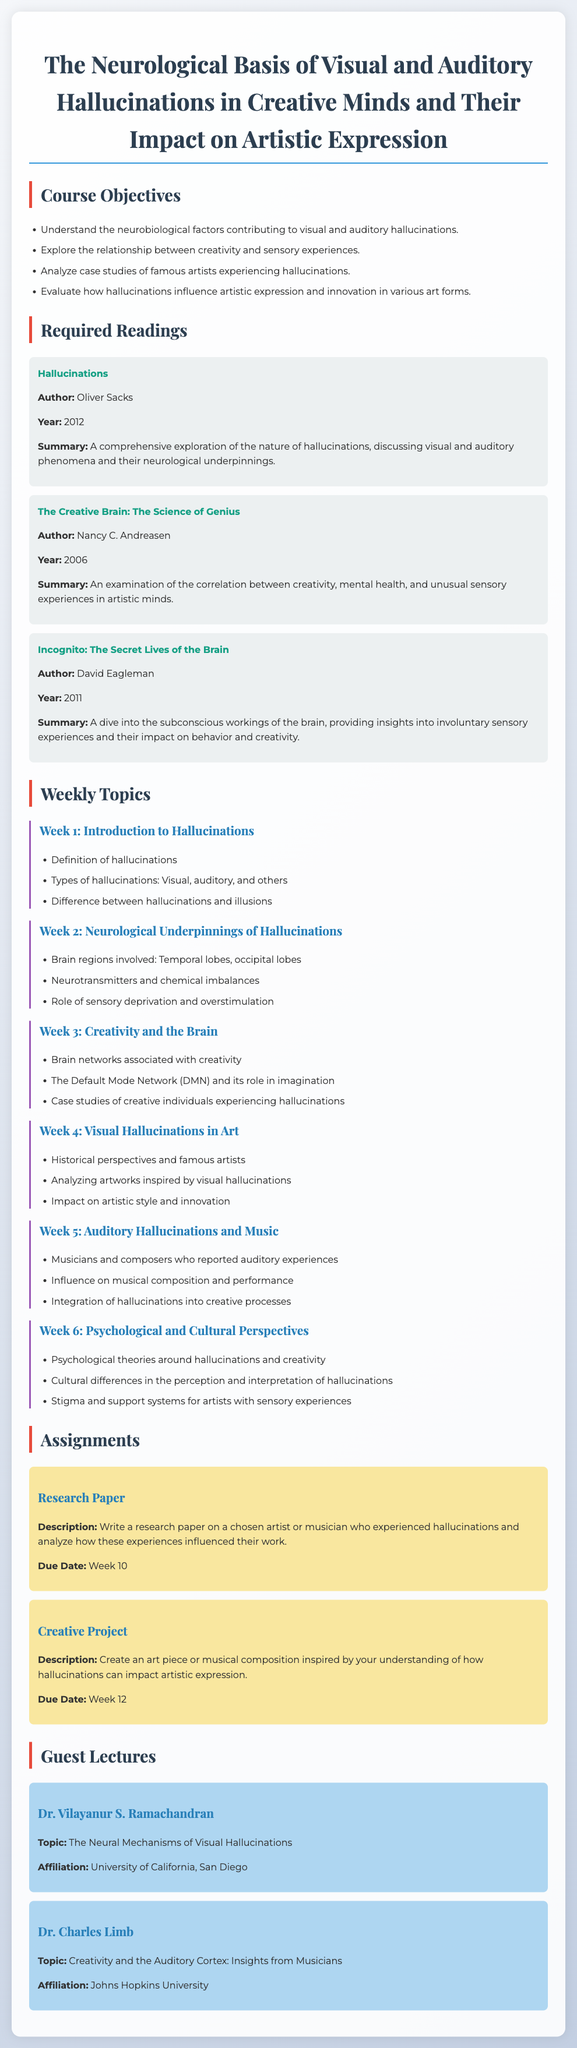What is the title of the course? The title of the course is the main heading at the beginning of the document, which outlines the focus of the syllabus.
Answer: The Neurological Basis of Visual and Auditory Hallucinations in Creative Minds and Their Impact on Artistic Expression Who is the author of the book "Hallucinations"? This detail can be found in the required readings section, identifying the author associated with each mentioned book.
Answer: Oliver Sacks What is the primary focus of Week 2? This information is found in the outline of weekly topics, specifying the subject matter for each week.
Answer: Neurological Underpinnings of Hallucinations What is the due date for the Research Paper assignment? The due date is provided in the assignment section, clearly stating when the task needs to be submitted.
Answer: Week 10 Who will lecture on the topic of auditory cortex and creativity? This question pertains to the guest lectures section, specifying the invited speakers and their topics.
Answer: Dr. Charles Limb What psychological aspect is discussed in Week 6? This relates to the main topics of the week listed in the syllabus, indicating the themes to be explored in each session.
Answer: Psychological and Cultural Perspectives How many required readings are listed? This counts the number of readings provided in the syllabus, indicating the resources to be used throughout the course.
Answer: Three In which year was "The Creative Brain: The Science of Genius" published? The publication year is included in each reading description to provide context and relevance of the texts.
Answer: 2006 